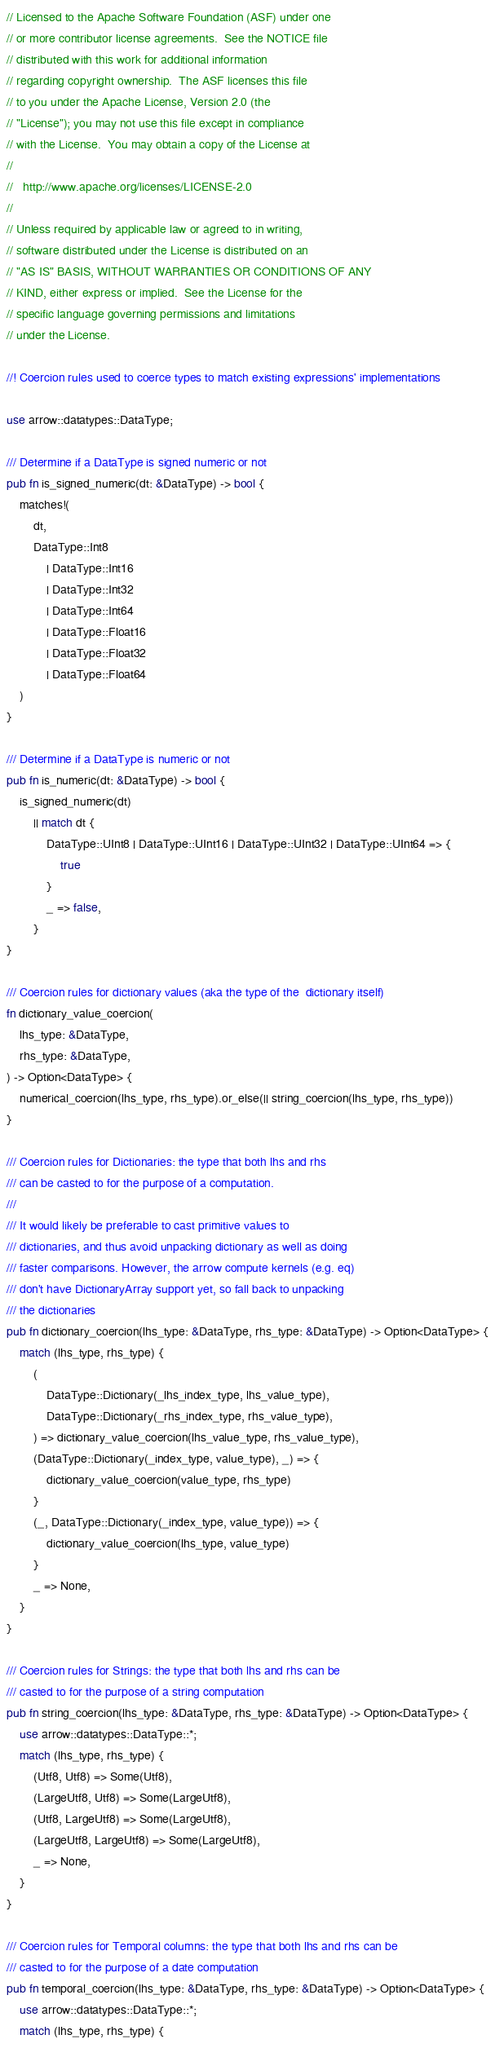<code> <loc_0><loc_0><loc_500><loc_500><_Rust_>// Licensed to the Apache Software Foundation (ASF) under one
// or more contributor license agreements.  See the NOTICE file
// distributed with this work for additional information
// regarding copyright ownership.  The ASF licenses this file
// to you under the Apache License, Version 2.0 (the
// "License"); you may not use this file except in compliance
// with the License.  You may obtain a copy of the License at
//
//   http://www.apache.org/licenses/LICENSE-2.0
//
// Unless required by applicable law or agreed to in writing,
// software distributed under the License is distributed on an
// "AS IS" BASIS, WITHOUT WARRANTIES OR CONDITIONS OF ANY
// KIND, either express or implied.  See the License for the
// specific language governing permissions and limitations
// under the License.

//! Coercion rules used to coerce types to match existing expressions' implementations

use arrow::datatypes::DataType;

/// Determine if a DataType is signed numeric or not
pub fn is_signed_numeric(dt: &DataType) -> bool {
    matches!(
        dt,
        DataType::Int8
            | DataType::Int16
            | DataType::Int32
            | DataType::Int64
            | DataType::Float16
            | DataType::Float32
            | DataType::Float64
    )
}

/// Determine if a DataType is numeric or not
pub fn is_numeric(dt: &DataType) -> bool {
    is_signed_numeric(dt)
        || match dt {
            DataType::UInt8 | DataType::UInt16 | DataType::UInt32 | DataType::UInt64 => {
                true
            }
            _ => false,
        }
}

/// Coercion rules for dictionary values (aka the type of the  dictionary itself)
fn dictionary_value_coercion(
    lhs_type: &DataType,
    rhs_type: &DataType,
) -> Option<DataType> {
    numerical_coercion(lhs_type, rhs_type).or_else(|| string_coercion(lhs_type, rhs_type))
}

/// Coercion rules for Dictionaries: the type that both lhs and rhs
/// can be casted to for the purpose of a computation.
///
/// It would likely be preferable to cast primitive values to
/// dictionaries, and thus avoid unpacking dictionary as well as doing
/// faster comparisons. However, the arrow compute kernels (e.g. eq)
/// don't have DictionaryArray support yet, so fall back to unpacking
/// the dictionaries
pub fn dictionary_coercion(lhs_type: &DataType, rhs_type: &DataType) -> Option<DataType> {
    match (lhs_type, rhs_type) {
        (
            DataType::Dictionary(_lhs_index_type, lhs_value_type),
            DataType::Dictionary(_rhs_index_type, rhs_value_type),
        ) => dictionary_value_coercion(lhs_value_type, rhs_value_type),
        (DataType::Dictionary(_index_type, value_type), _) => {
            dictionary_value_coercion(value_type, rhs_type)
        }
        (_, DataType::Dictionary(_index_type, value_type)) => {
            dictionary_value_coercion(lhs_type, value_type)
        }
        _ => None,
    }
}

/// Coercion rules for Strings: the type that both lhs and rhs can be
/// casted to for the purpose of a string computation
pub fn string_coercion(lhs_type: &DataType, rhs_type: &DataType) -> Option<DataType> {
    use arrow::datatypes::DataType::*;
    match (lhs_type, rhs_type) {
        (Utf8, Utf8) => Some(Utf8),
        (LargeUtf8, Utf8) => Some(LargeUtf8),
        (Utf8, LargeUtf8) => Some(LargeUtf8),
        (LargeUtf8, LargeUtf8) => Some(LargeUtf8),
        _ => None,
    }
}

/// Coercion rules for Temporal columns: the type that both lhs and rhs can be
/// casted to for the purpose of a date computation
pub fn temporal_coercion(lhs_type: &DataType, rhs_type: &DataType) -> Option<DataType> {
    use arrow::datatypes::DataType::*;
    match (lhs_type, rhs_type) {</code> 